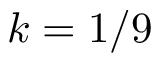<formula> <loc_0><loc_0><loc_500><loc_500>k = 1 / 9</formula> 